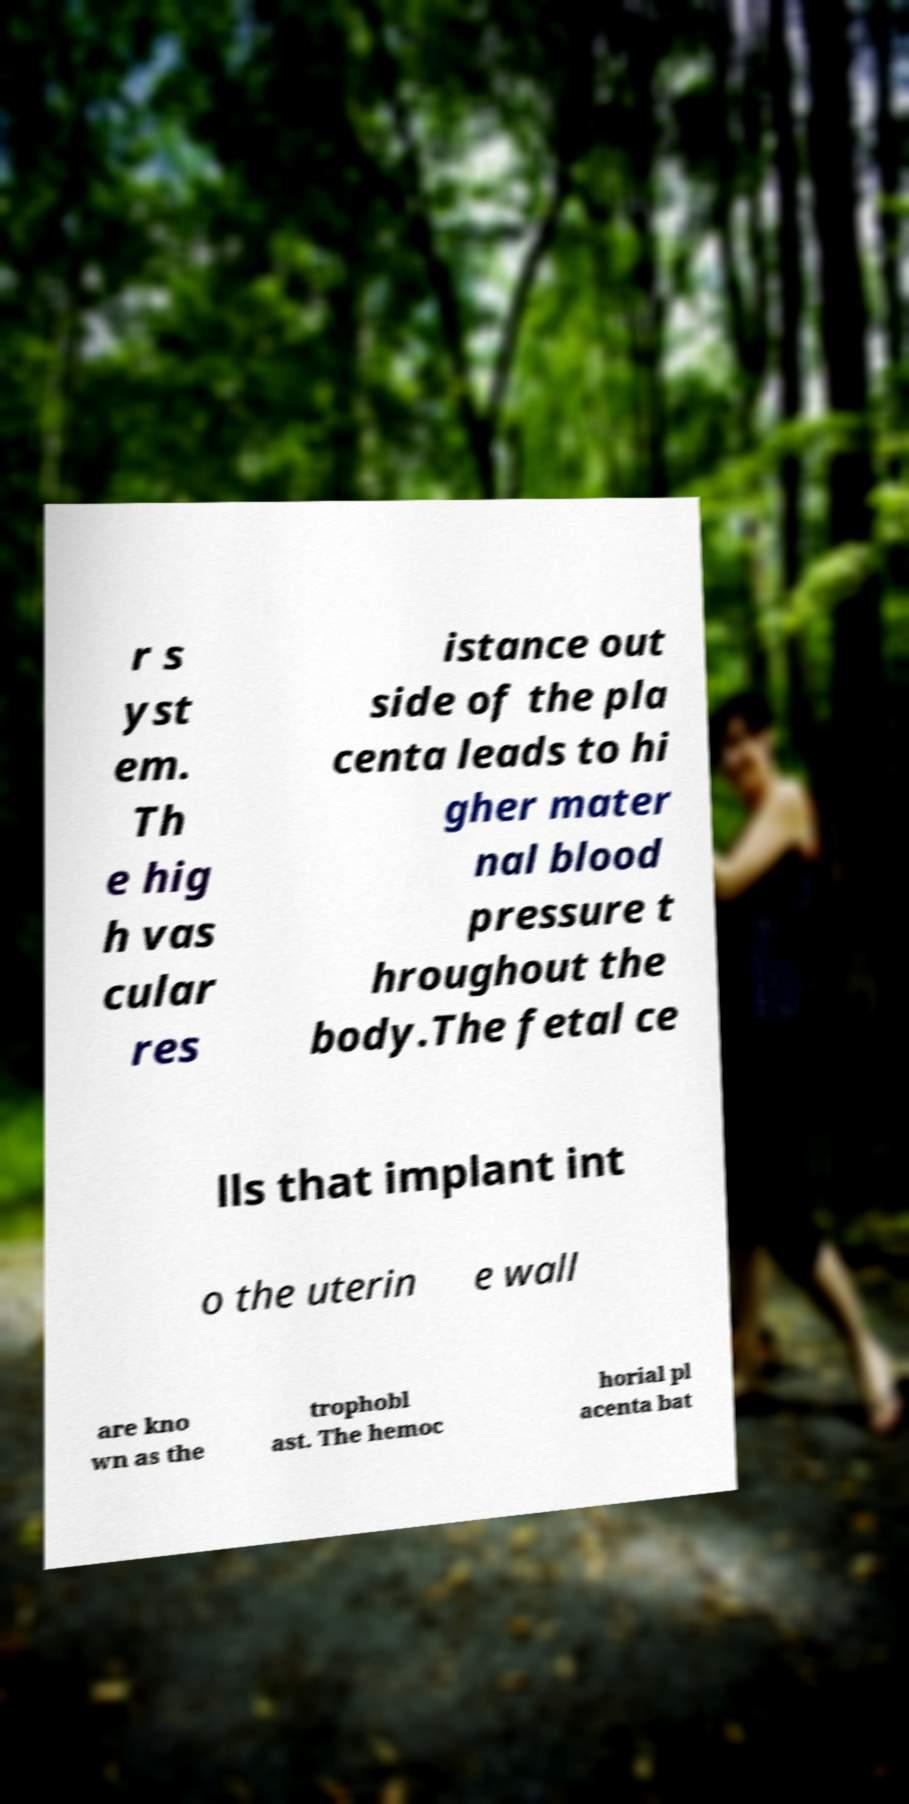Please identify and transcribe the text found in this image. r s yst em. Th e hig h vas cular res istance out side of the pla centa leads to hi gher mater nal blood pressure t hroughout the body.The fetal ce lls that implant int o the uterin e wall are kno wn as the trophobl ast. The hemoc horial pl acenta bat 